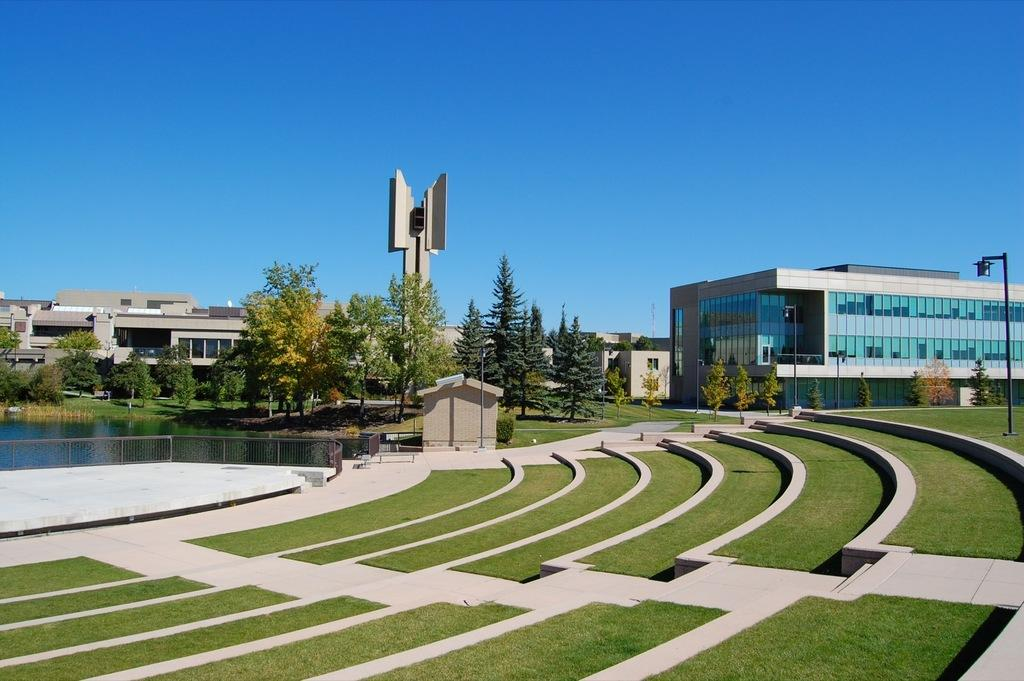What can be seen at the bottom of the image? The ground is visible in the image. What is located to the left of the image? There is a railing and water to the left of the image. What is present to the right of the image? There is a light pole to the right of the image. What is visible in the background of the image? Trees, buildings, and the blue sky are visible in the background of the image. How many chairs are arranged in a specific order for a bath in the image? There are no chairs or baths present in the image. What type of creature is seen taking a bath in the image? There is no creature taking a bath in the image; it features a railing, water, a light pole, trees, buildings, and a blue sky in the background. 